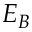Convert formula to latex. <formula><loc_0><loc_0><loc_500><loc_500>E _ { B }</formula> 